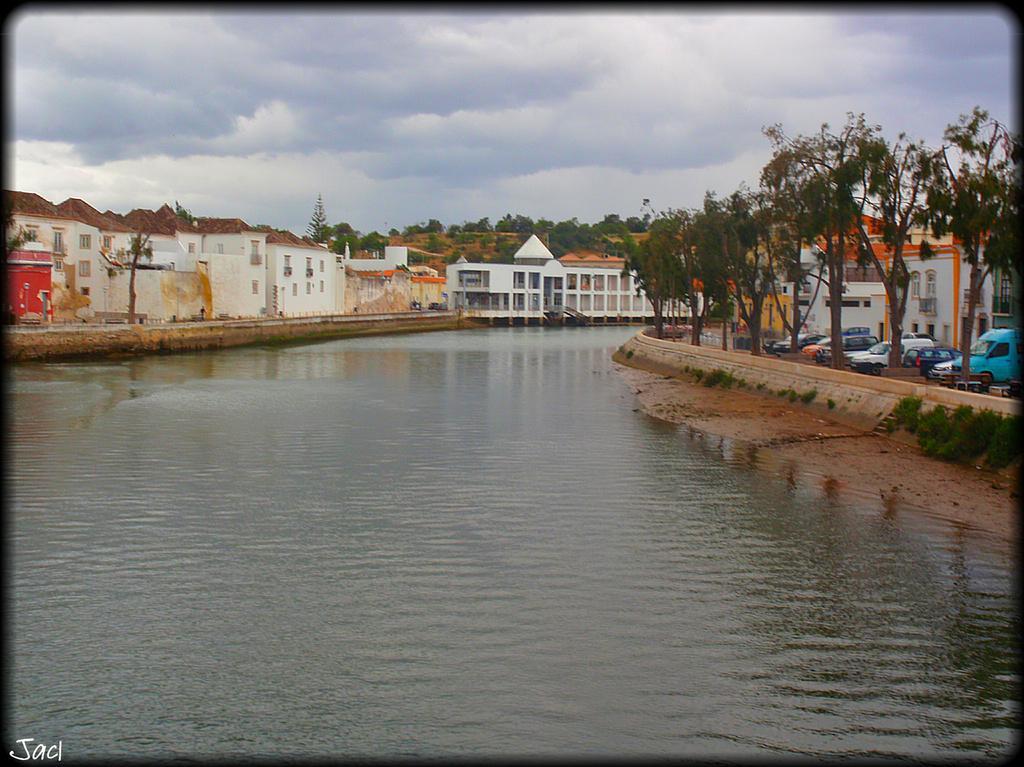Can you describe this image briefly? At the bottom of the picture, we see water. Beside that, there are cars and vehicles parked. Beside that, there are trees. There are many trees and building in the background. At the top of the picture, we see the sky. 